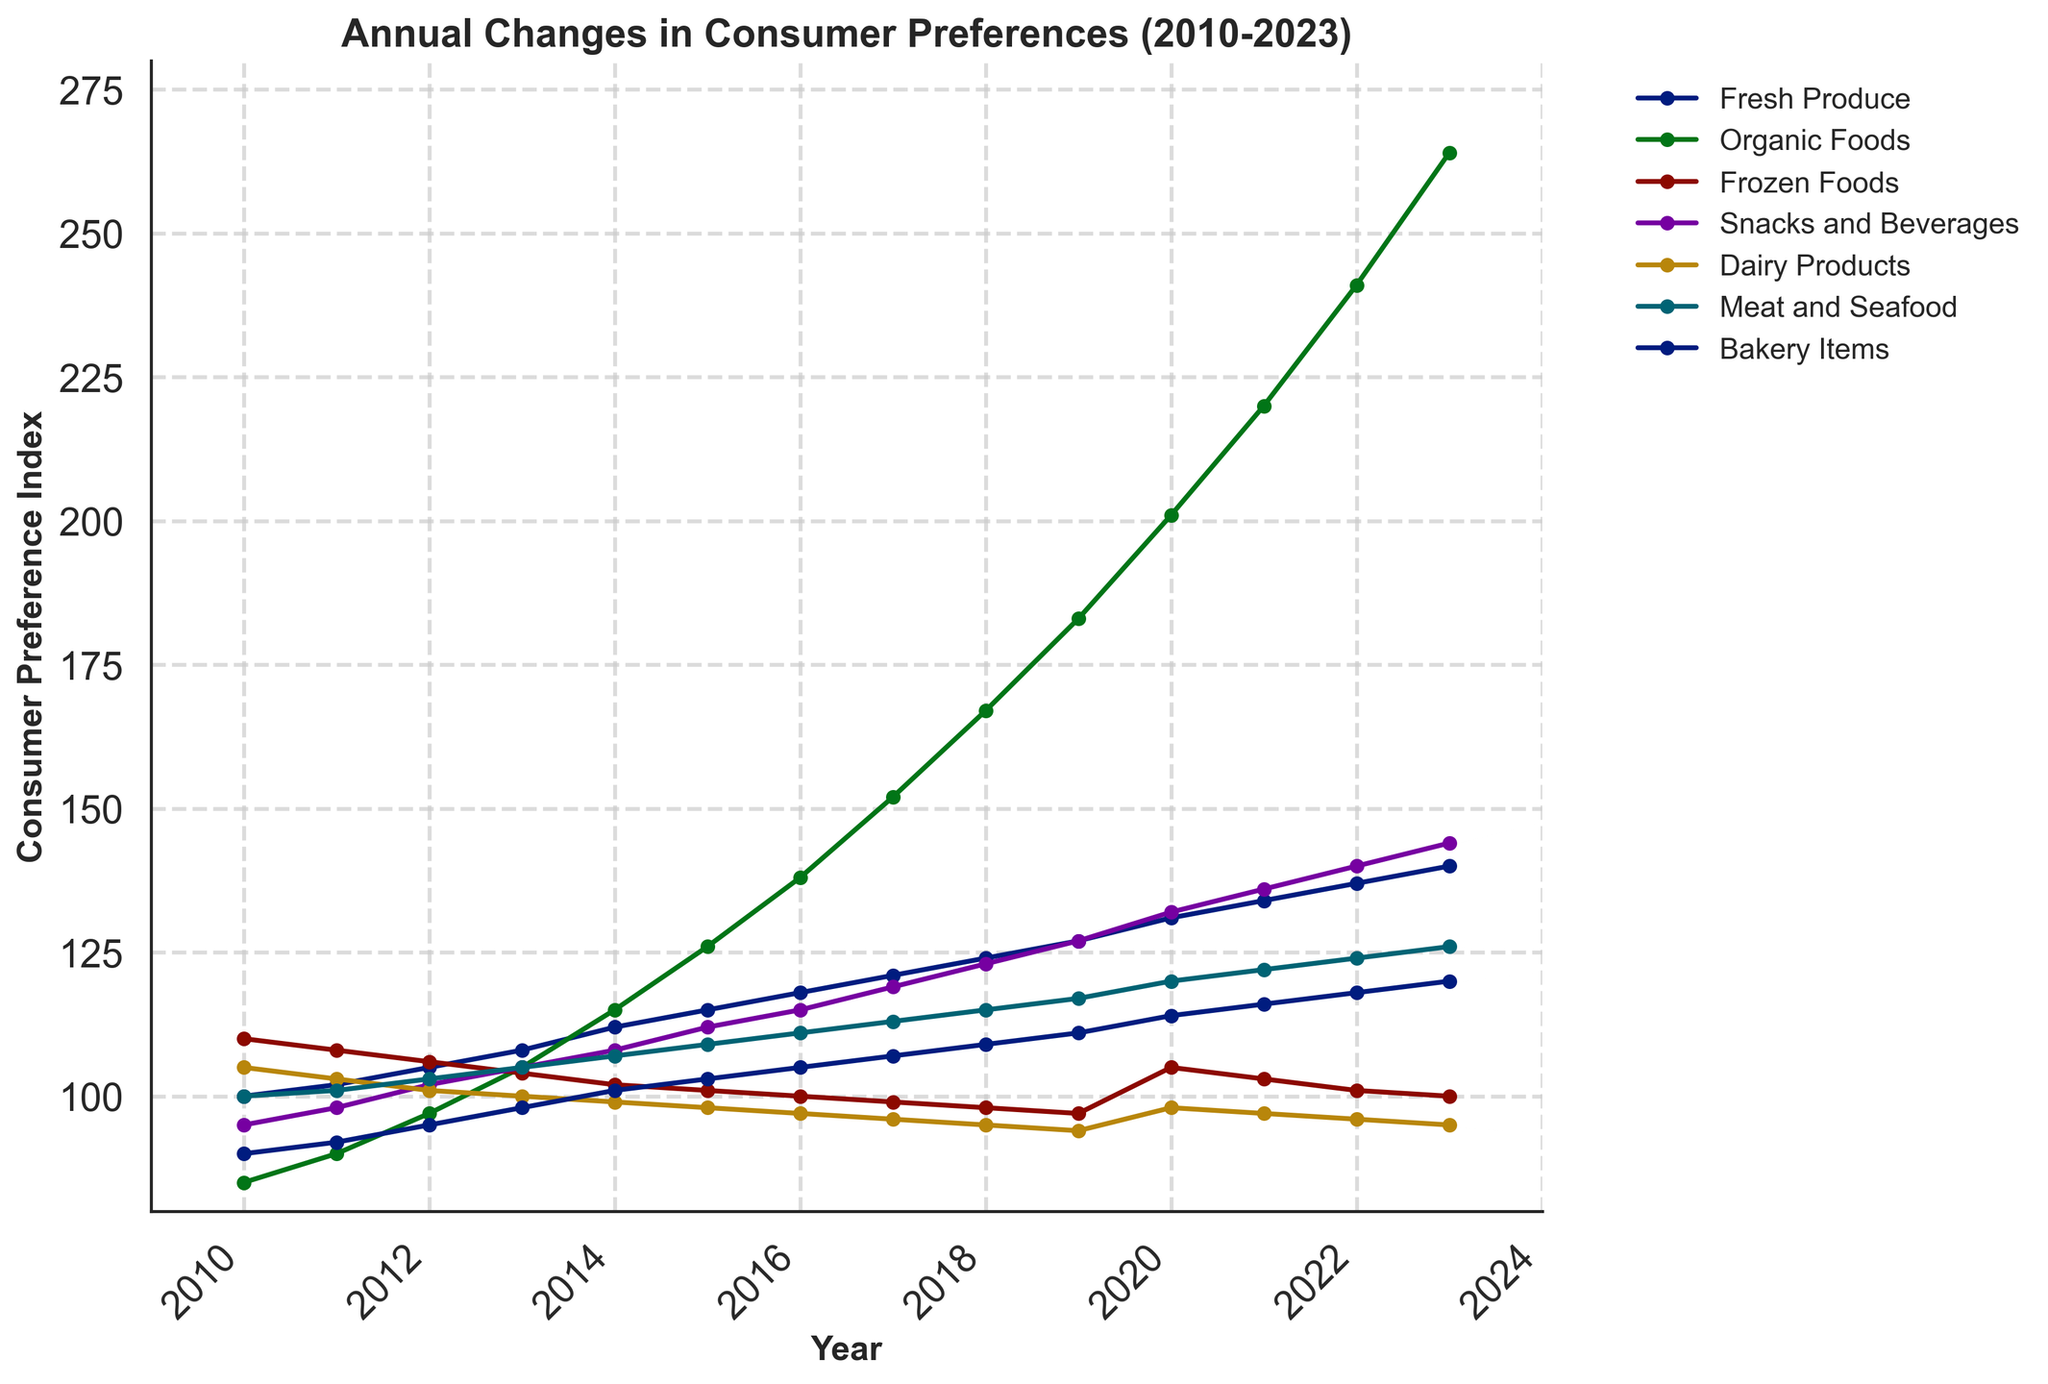Which food category experienced the highest increase in consumer preference from 2010 to 2023? To determine this, you need to find the difference between the 2023 and 2010 values for each category. The greatest difference indicates the highest increase. Here are the differences: Fresh Produce (140-100=40), Organic Foods (264-85=179), Frozen Foods (100-110=-10), Snacks and Beverages (144-95=49), Dairy Products (95-105=-10), Meat and Seafood (126-100=26), Bakery Items (120-90=30). The highest increase is for Organic Foods (179).
Answer: Organic Foods Which year did Meat and Seafood first surpass 115 on the consumer preference index? Examine the values for Meat and Seafood over the years: 2010 (100), 2011 (101), 2012 (103), 2013 (105), 2014 (107), 2015 (109), 2016 (111), 2017 (113), 2018 (115), 2019 (117). The value first surpasses 115 in 2019.
Answer: 2019 What is the difference between the highest and the lowest consumer preference index value for Dairy Products over the period? Identify the highest and lowest values for Dairy Products from the data: Highest (105 in 2010), Lowest (95 from 2018 to 2023). The difference is 105 - 95.
Answer: 10 How did the preferences for Frozen Foods change in the years 2019 to 2023? Review the Consumer Preference Index for Frozen Foods from 2019 to 2023: 2019 (97), 2020 (105), 2021 (103), 2022 (101), 2023 (100). Observe the sequence to note the change: initially increased in 2020, then decreased for subsequent years.
Answer: Increased in 2020, then decreased Which category had the most consistent consumer preference index from 2010 to 2023? Consistency can be determined by examining the least variation (least difference between consecutive year values). Evaluate the values for each category year-over-year. For Bakery Items, the differences are small and consistent: 90, 92, 95, 98, 101, 103, 105, 107, 109, 111, 114, 116, 118, 120. Other categories exhibit larger fluctuations.
Answer: Bakery Items 